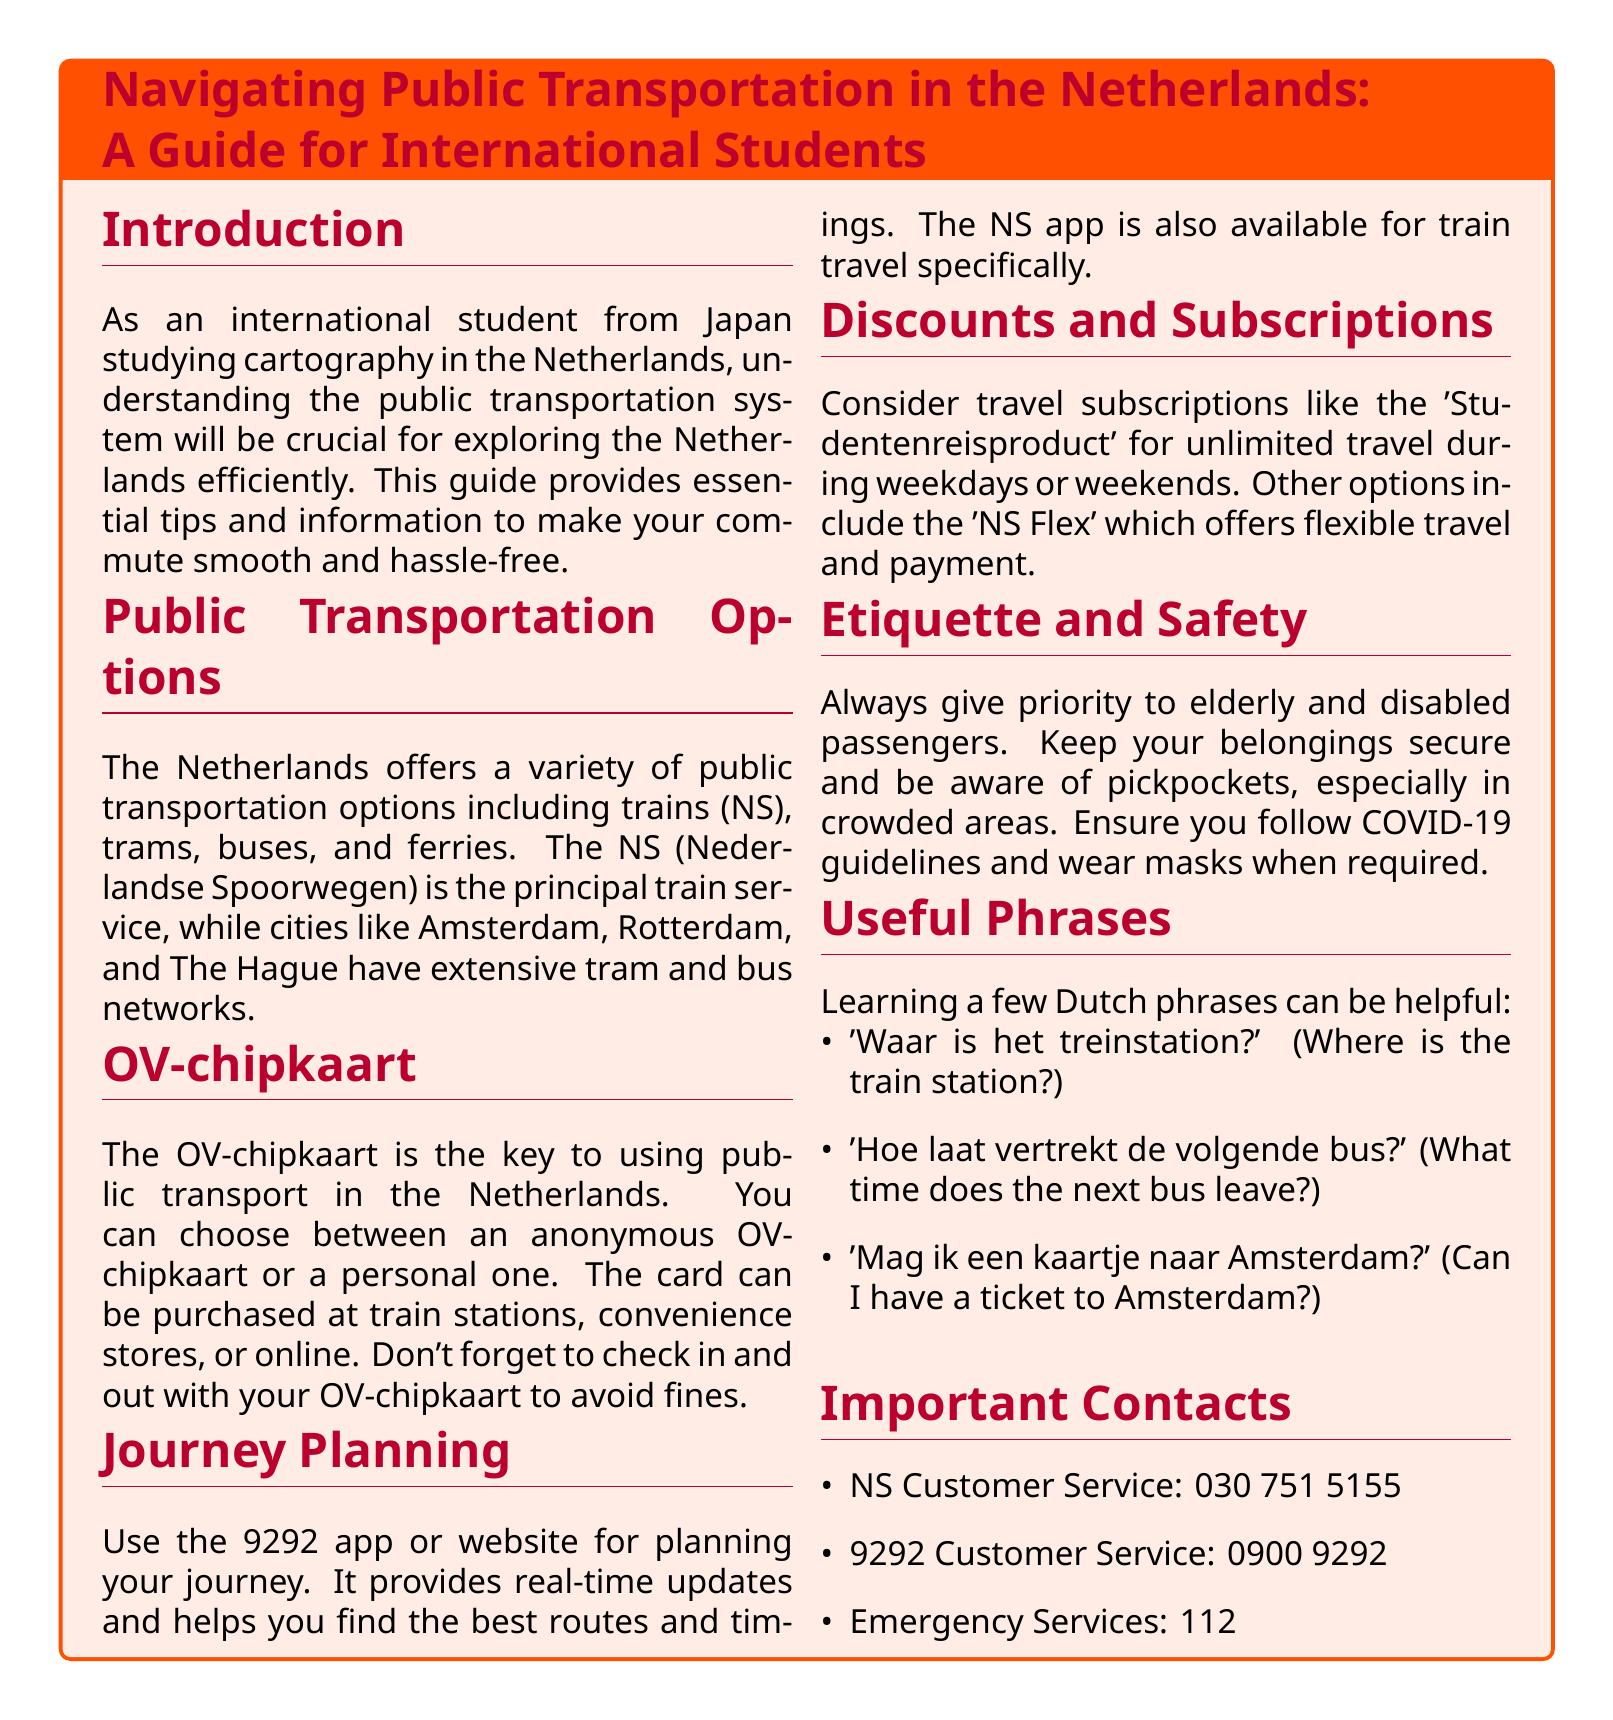What is the key to using public transport in the Netherlands? The OV-chipkaart is highlighted as the essential card for using public transport.
Answer: OV-chipkaart Which app is recommended for journey planning? The document mentions the 9292 app for journey planning.
Answer: 9292 What is the contact number for NS Customer Service? The NS Customer Service contact number is provided in the document.
Answer: 030 751 5155 What type of OV-chipkaart can you choose from? The document states that you can choose between an anonymous or a personal OV-chipkaart.
Answer: Anonymous or personal What travel subscription allows unlimited travel during weekdays? The document lists the 'Studentenreisproduct' as the travel subscription for unlimited travel on weekdays.
Answer: Studentenreisproduct What is a safety tip provided in the document? The document suggests keeping your belongings secure and being aware of pickpockets, especially in crowded areas.
Answer: Keep belongings secure Which phrase translates to "Where is the train station?" in Dutch? The document lists phrases with their translations, one of which is "Waar is het treinstation?"
Answer: Waar is het treinstation? What type of public transportation does NS refer to? NS is identified as the principal train service in the Netherlands.
Answer: Train service How can you purchase the OV-chipkaart? The document explains that the OV-chipkaart can be purchased at train stations, convenience stores, or online.
Answer: Train stations, convenience stores, or online 